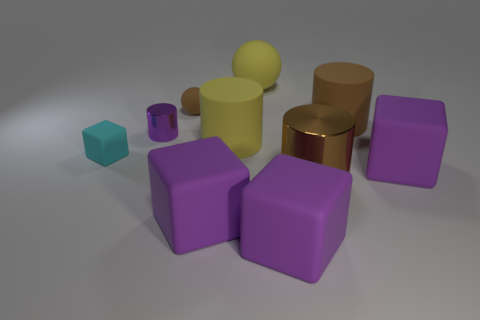The other purple object that is the same shape as the big shiny thing is what size?
Provide a succinct answer. Small. There is a large purple rubber object that is right of the big brown rubber object behind the small matte object in front of the small purple metallic object; what is its shape?
Offer a terse response. Cube. There is a large ball that is made of the same material as the small brown sphere; what is its color?
Offer a terse response. Yellow. What is the color of the small rubber object that is behind the shiny thing that is behind the brown object in front of the tiny matte cube?
Make the answer very short. Brown. What number of cubes are big yellow matte objects or cyan things?
Keep it short and to the point. 1. Is the color of the large sphere the same as the tiny matte thing that is behind the small purple metal cylinder?
Make the answer very short. No. The small cylinder has what color?
Provide a short and direct response. Purple. How many objects are large brown rubber cylinders or brown objects?
Make the answer very short. 3. There is a cylinder that is the same size as the brown rubber sphere; what material is it?
Your response must be concise. Metal. There is a cylinder to the left of the brown matte sphere; what is its size?
Offer a terse response. Small. 